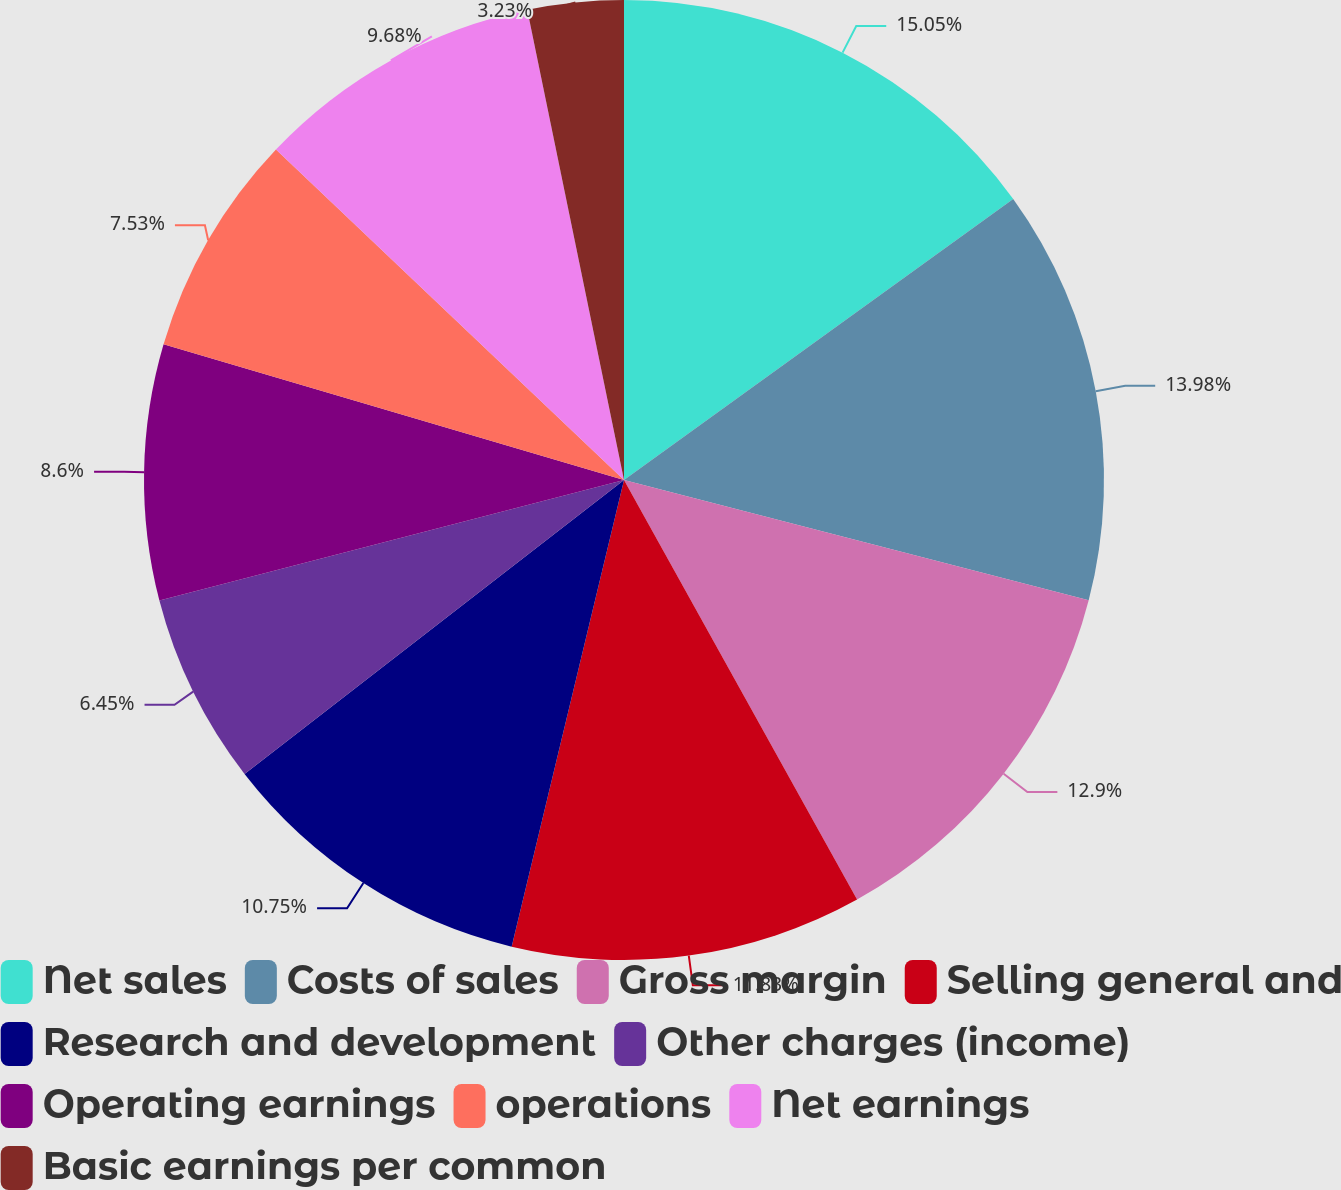Convert chart. <chart><loc_0><loc_0><loc_500><loc_500><pie_chart><fcel>Net sales<fcel>Costs of sales<fcel>Gross margin<fcel>Selling general and<fcel>Research and development<fcel>Other charges (income)<fcel>Operating earnings<fcel>operations<fcel>Net earnings<fcel>Basic earnings per common<nl><fcel>15.05%<fcel>13.98%<fcel>12.9%<fcel>11.83%<fcel>10.75%<fcel>6.45%<fcel>8.6%<fcel>7.53%<fcel>9.68%<fcel>3.23%<nl></chart> 